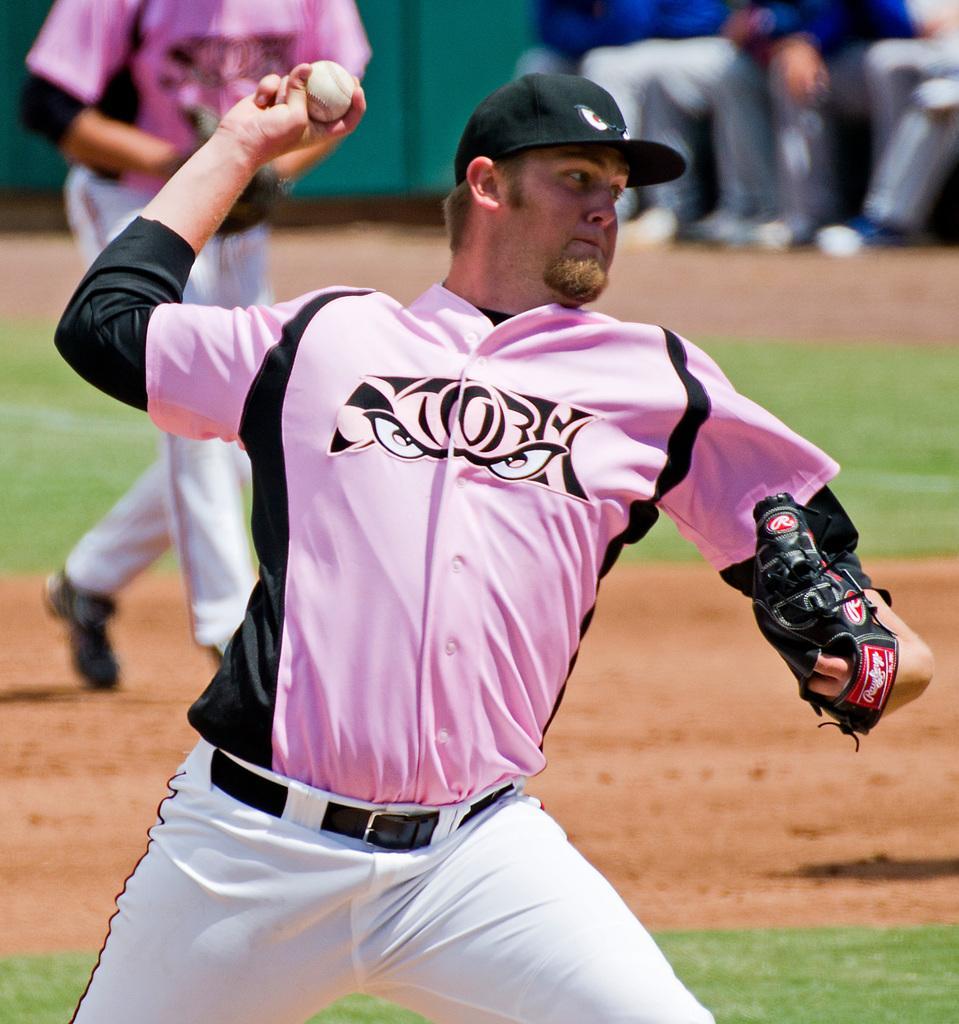Can you describe this image briefly? This is a playing ground. Here I can see a man wearing pink color shirt, black color cap on the head, holding a ball in the hand and looking towards the right side. It seems like he is throwing the ball. At the back of this man I can see another person is running on the ground. On the right top of the image I can see few people are sitting. At the bottom of of the image I can see the grass. 